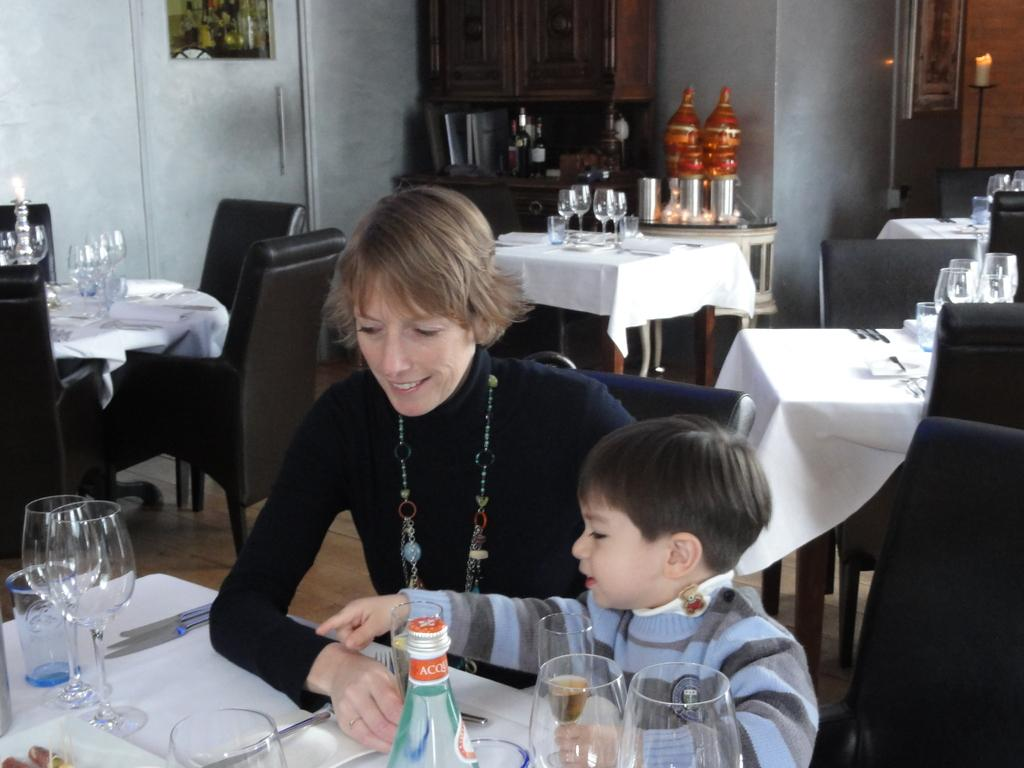Who are the people in the image? There is a woman and a boy in the image. What are the woman and the boy doing in the image? The woman and the boy are seated. What objects can be seen on the table in the image? There are glasses, bottles, and knives on the table. What type of shade is covering the sky in the image? There is no shade covering the sky in the image, as the sky is not visible in the image. 